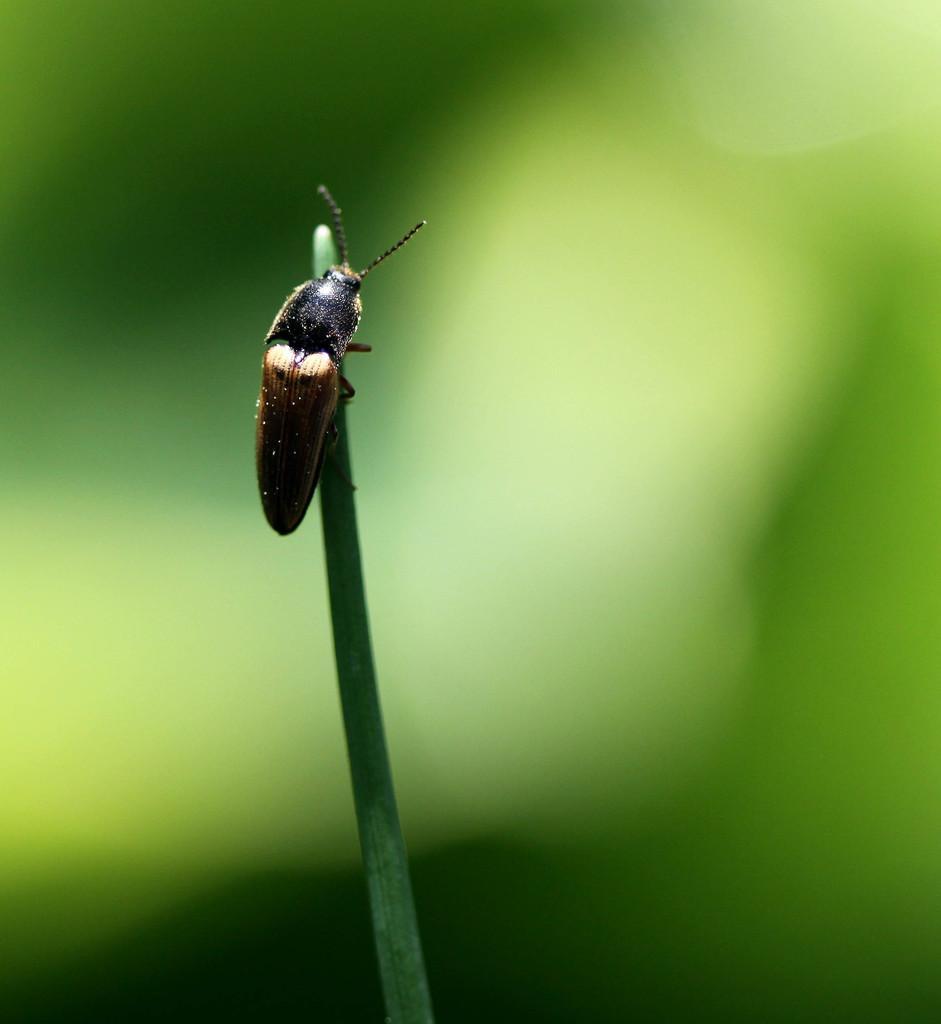Please provide a concise description of this image. In this image I can see an insect on a plant. The background is covered with green color. This image is taken may be in a garden. 